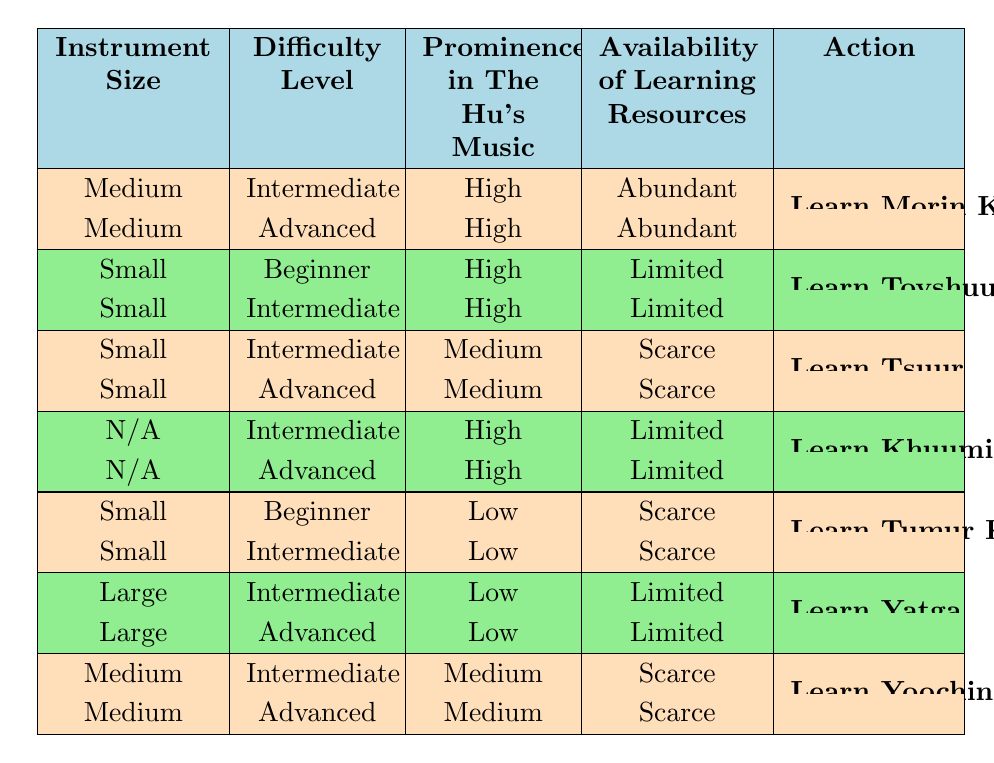What instrument is recommended for learners at an intermediate difficulty level with high prominence in The Hu's music? According to the table, for an intermediate difficulty level and high prominence, the recommended instrument is the Morin Khuur with abundant learning resources.
Answer: Morin Khuur Is there a traditional Mongolian instrument that is small in size and suitable for beginner learners? Yes, the Tovshuur is suitable for beginner learners and is small in size, though learning resources are limited.
Answer: Yes How many instruments can be learned at an advanced level that have high prominence in The Hu's music? The table indicates two instruments with advanced difficulty and high prominence in The Hu's music: Morin Khuur and Khuumii (Throat Singing). Thus, there are two instruments.
Answer: 2 Are there any instruments that have scarce availability of learning resources? Yes, the Tsuur, Tumur Khuur, and Yoochin have scarce availability of learning resources as indicated in their respective rows.
Answer: Yes Which instrument is the only one with a large size and limited resources, and what is its difficulty level? The Yatga is the only instrument listed as large in size, with limited resources, and it is offered at both intermediate and advanced difficulty levels.
Answer: Yatga, Intermediate/Advanced 